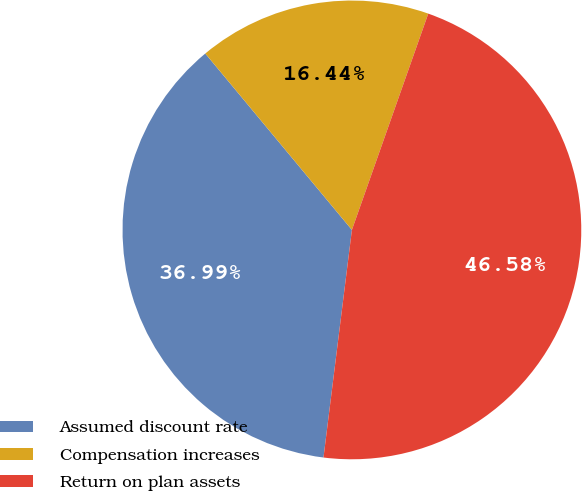Convert chart to OTSL. <chart><loc_0><loc_0><loc_500><loc_500><pie_chart><fcel>Assumed discount rate<fcel>Compensation increases<fcel>Return on plan assets<nl><fcel>36.99%<fcel>16.44%<fcel>46.58%<nl></chart> 